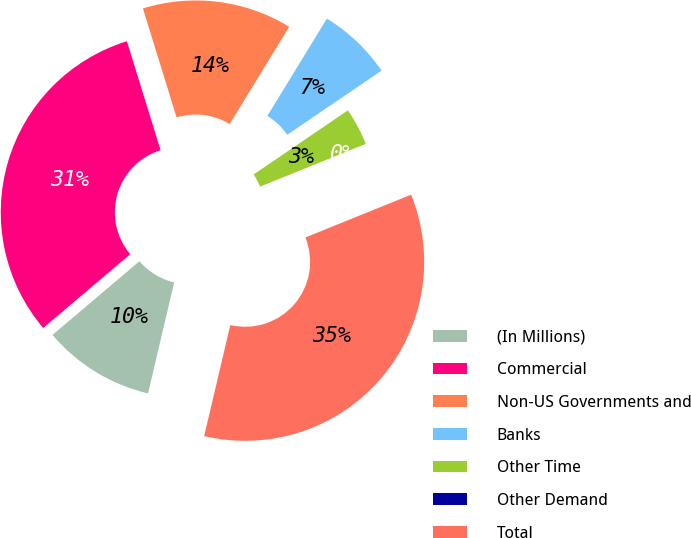<chart> <loc_0><loc_0><loc_500><loc_500><pie_chart><fcel>(In Millions)<fcel>Commercial<fcel>Non-US Governments and<fcel>Banks<fcel>Other Time<fcel>Other Demand<fcel>Total<nl><fcel>10.13%<fcel>31.42%<fcel>13.51%<fcel>6.76%<fcel>3.38%<fcel>0.0%<fcel>34.8%<nl></chart> 